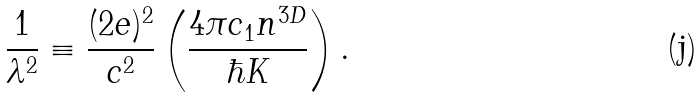Convert formula to latex. <formula><loc_0><loc_0><loc_500><loc_500>\frac { 1 } { \lambda ^ { 2 } } \equiv \frac { ( 2 e ) ^ { 2 } } { c ^ { 2 } } \left ( \frac { 4 \pi c _ { 1 } n ^ { 3 D } } { \hbar { K } } \right ) .</formula> 